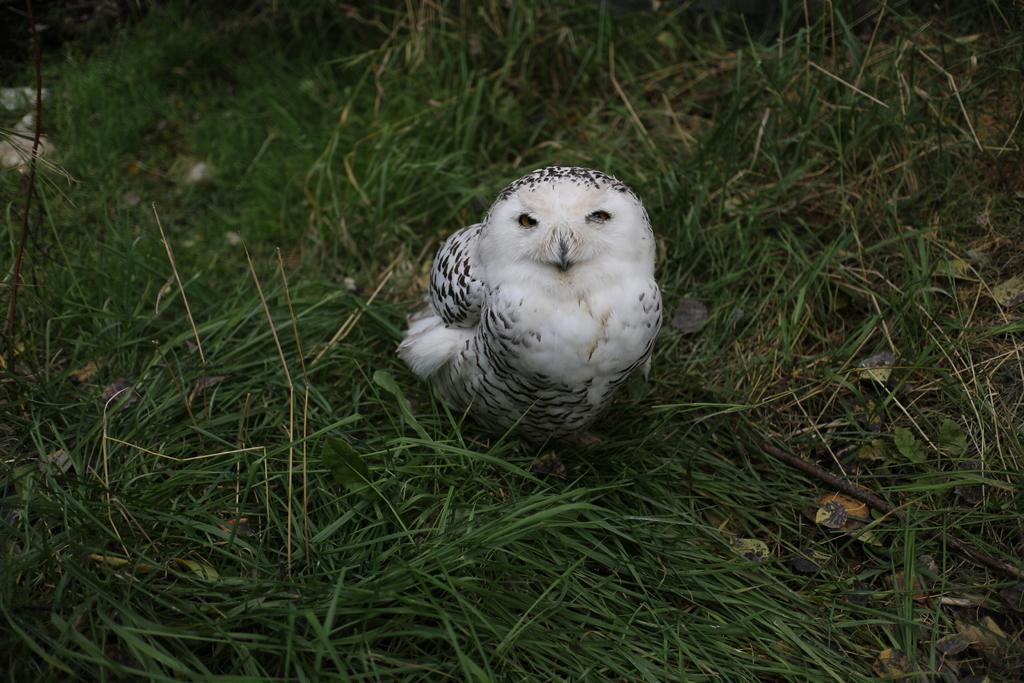Describe this image in one or two sentences. In this image there is a bird on the grassland. 